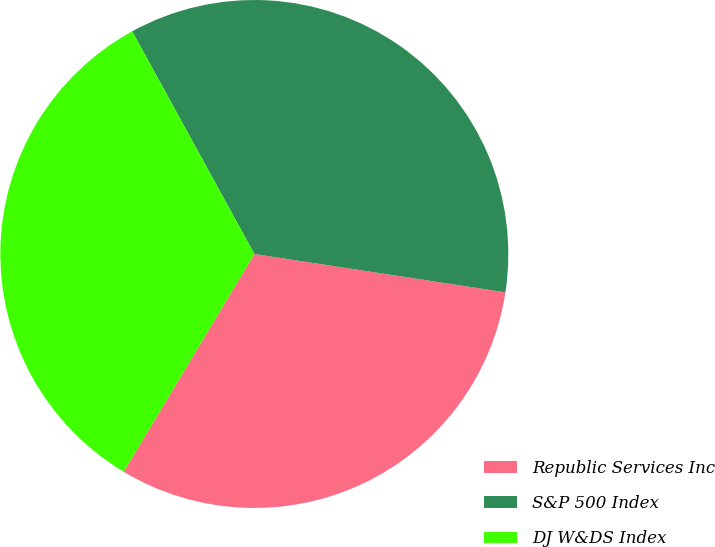Convert chart to OTSL. <chart><loc_0><loc_0><loc_500><loc_500><pie_chart><fcel>Republic Services Inc<fcel>S&P 500 Index<fcel>DJ W&DS Index<nl><fcel>31.19%<fcel>35.4%<fcel>33.41%<nl></chart> 